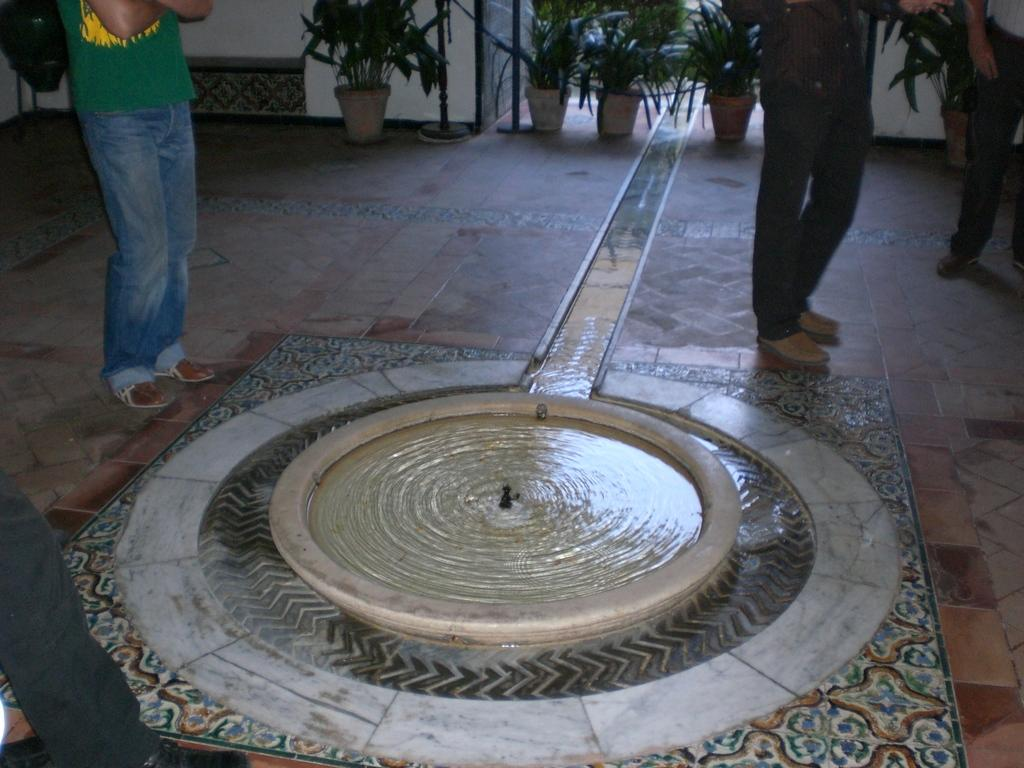What is happening in the image? There are people standing on the floor in the image. What can be seen in the middle of the image? There is a structure that resembles a water pond in the middle of the image. What type of vegetation is present in the background of the image? There are potted plants in the background of the image. What type of example is being demonstrated in the image? There is no example being demonstrated in the image; it simply shows people standing near a water pond with potted plants in the background. Is there a volleyball game happening in the image? No, there is no volleyball game or any reference to volleyball in the image. 